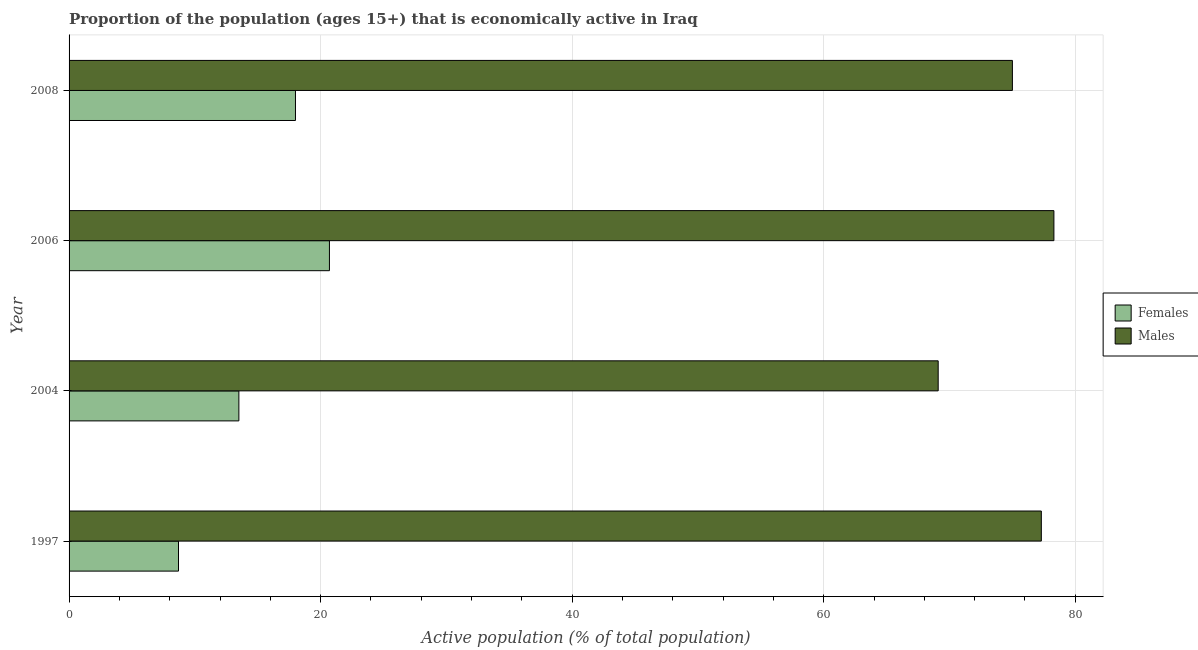How many different coloured bars are there?
Ensure brevity in your answer.  2. How many groups of bars are there?
Your response must be concise. 4. Are the number of bars per tick equal to the number of legend labels?
Provide a short and direct response. Yes. Are the number of bars on each tick of the Y-axis equal?
Offer a terse response. Yes. How many bars are there on the 1st tick from the top?
Ensure brevity in your answer.  2. How many bars are there on the 3rd tick from the bottom?
Make the answer very short. 2. What is the label of the 4th group of bars from the top?
Your response must be concise. 1997. What is the percentage of economically active male population in 1997?
Make the answer very short. 77.3. Across all years, what is the maximum percentage of economically active female population?
Your answer should be compact. 20.7. Across all years, what is the minimum percentage of economically active male population?
Your response must be concise. 69.1. What is the total percentage of economically active female population in the graph?
Your answer should be very brief. 60.9. What is the difference between the percentage of economically active female population in 1997 and that in 2006?
Ensure brevity in your answer.  -12. What is the difference between the percentage of economically active female population in 1997 and the percentage of economically active male population in 2006?
Your response must be concise. -69.6. What is the average percentage of economically active male population per year?
Make the answer very short. 74.92. In the year 2008, what is the difference between the percentage of economically active female population and percentage of economically active male population?
Ensure brevity in your answer.  -57. In how many years, is the percentage of economically active male population greater than 56 %?
Offer a terse response. 4. What is the ratio of the percentage of economically active male population in 2004 to that in 2008?
Provide a succinct answer. 0.92. Is the percentage of economically active female population in 1997 less than that in 2006?
Make the answer very short. Yes. In how many years, is the percentage of economically active male population greater than the average percentage of economically active male population taken over all years?
Provide a succinct answer. 3. What does the 1st bar from the top in 1997 represents?
Offer a very short reply. Males. What does the 2nd bar from the bottom in 2006 represents?
Provide a short and direct response. Males. Are all the bars in the graph horizontal?
Offer a terse response. Yes. How many years are there in the graph?
Offer a terse response. 4. Are the values on the major ticks of X-axis written in scientific E-notation?
Ensure brevity in your answer.  No. Does the graph contain any zero values?
Your answer should be compact. No. How are the legend labels stacked?
Your answer should be compact. Vertical. What is the title of the graph?
Ensure brevity in your answer.  Proportion of the population (ages 15+) that is economically active in Iraq. Does "Fixed telephone" appear as one of the legend labels in the graph?
Make the answer very short. No. What is the label or title of the X-axis?
Provide a short and direct response. Active population (% of total population). What is the Active population (% of total population) of Females in 1997?
Offer a terse response. 8.7. What is the Active population (% of total population) in Males in 1997?
Provide a succinct answer. 77.3. What is the Active population (% of total population) in Females in 2004?
Offer a terse response. 13.5. What is the Active population (% of total population) in Males in 2004?
Give a very brief answer. 69.1. What is the Active population (% of total population) of Females in 2006?
Provide a succinct answer. 20.7. What is the Active population (% of total population) in Males in 2006?
Provide a succinct answer. 78.3. What is the Active population (% of total population) in Females in 2008?
Give a very brief answer. 18. Across all years, what is the maximum Active population (% of total population) of Females?
Offer a very short reply. 20.7. Across all years, what is the maximum Active population (% of total population) of Males?
Your answer should be very brief. 78.3. Across all years, what is the minimum Active population (% of total population) in Females?
Offer a very short reply. 8.7. Across all years, what is the minimum Active population (% of total population) of Males?
Your answer should be compact. 69.1. What is the total Active population (% of total population) of Females in the graph?
Ensure brevity in your answer.  60.9. What is the total Active population (% of total population) in Males in the graph?
Provide a short and direct response. 299.7. What is the difference between the Active population (% of total population) in Females in 1997 and that in 2004?
Provide a short and direct response. -4.8. What is the difference between the Active population (% of total population) in Males in 1997 and that in 2008?
Give a very brief answer. 2.3. What is the difference between the Active population (% of total population) in Females in 2004 and that in 2006?
Provide a succinct answer. -7.2. What is the difference between the Active population (% of total population) in Males in 2004 and that in 2006?
Your answer should be compact. -9.2. What is the difference between the Active population (% of total population) of Females in 1997 and the Active population (% of total population) of Males in 2004?
Ensure brevity in your answer.  -60.4. What is the difference between the Active population (% of total population) of Females in 1997 and the Active population (% of total population) of Males in 2006?
Make the answer very short. -69.6. What is the difference between the Active population (% of total population) in Females in 1997 and the Active population (% of total population) in Males in 2008?
Give a very brief answer. -66.3. What is the difference between the Active population (% of total population) of Females in 2004 and the Active population (% of total population) of Males in 2006?
Ensure brevity in your answer.  -64.8. What is the difference between the Active population (% of total population) in Females in 2004 and the Active population (% of total population) in Males in 2008?
Your answer should be very brief. -61.5. What is the difference between the Active population (% of total population) in Females in 2006 and the Active population (% of total population) in Males in 2008?
Make the answer very short. -54.3. What is the average Active population (% of total population) in Females per year?
Ensure brevity in your answer.  15.22. What is the average Active population (% of total population) in Males per year?
Your answer should be very brief. 74.92. In the year 1997, what is the difference between the Active population (% of total population) in Females and Active population (% of total population) in Males?
Provide a short and direct response. -68.6. In the year 2004, what is the difference between the Active population (% of total population) of Females and Active population (% of total population) of Males?
Provide a short and direct response. -55.6. In the year 2006, what is the difference between the Active population (% of total population) of Females and Active population (% of total population) of Males?
Provide a succinct answer. -57.6. In the year 2008, what is the difference between the Active population (% of total population) of Females and Active population (% of total population) of Males?
Offer a very short reply. -57. What is the ratio of the Active population (% of total population) in Females in 1997 to that in 2004?
Make the answer very short. 0.64. What is the ratio of the Active population (% of total population) of Males in 1997 to that in 2004?
Offer a terse response. 1.12. What is the ratio of the Active population (% of total population) in Females in 1997 to that in 2006?
Your answer should be compact. 0.42. What is the ratio of the Active population (% of total population) of Males in 1997 to that in 2006?
Make the answer very short. 0.99. What is the ratio of the Active population (% of total population) in Females in 1997 to that in 2008?
Ensure brevity in your answer.  0.48. What is the ratio of the Active population (% of total population) of Males in 1997 to that in 2008?
Offer a very short reply. 1.03. What is the ratio of the Active population (% of total population) of Females in 2004 to that in 2006?
Keep it short and to the point. 0.65. What is the ratio of the Active population (% of total population) of Males in 2004 to that in 2006?
Ensure brevity in your answer.  0.88. What is the ratio of the Active population (% of total population) in Females in 2004 to that in 2008?
Provide a succinct answer. 0.75. What is the ratio of the Active population (% of total population) of Males in 2004 to that in 2008?
Make the answer very short. 0.92. What is the ratio of the Active population (% of total population) in Females in 2006 to that in 2008?
Keep it short and to the point. 1.15. What is the ratio of the Active population (% of total population) in Males in 2006 to that in 2008?
Your response must be concise. 1.04. What is the difference between the highest and the lowest Active population (% of total population) in Females?
Give a very brief answer. 12. 